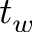Convert formula to latex. <formula><loc_0><loc_0><loc_500><loc_500>t _ { w }</formula> 